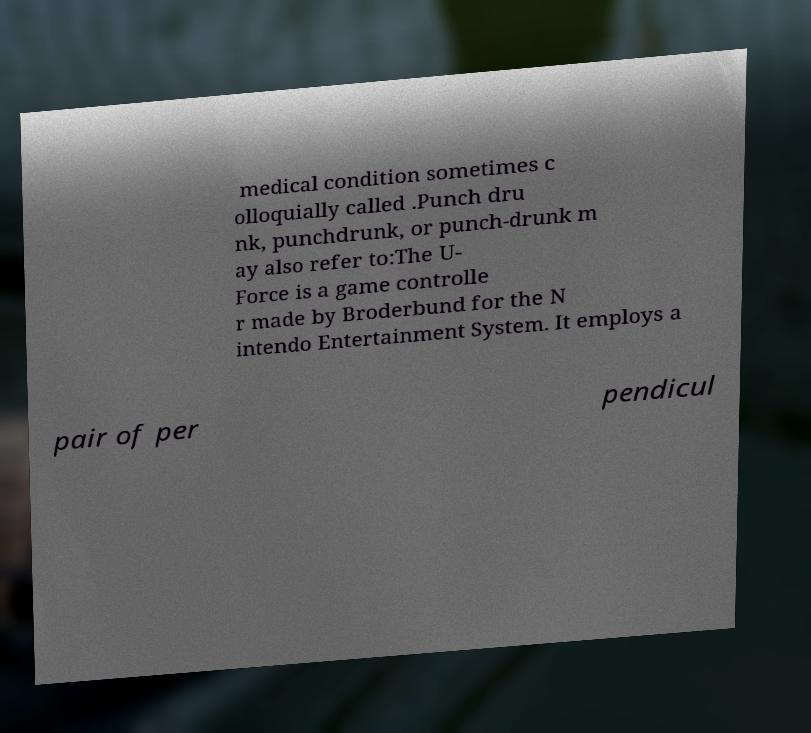There's text embedded in this image that I need extracted. Can you transcribe it verbatim? medical condition sometimes c olloquially called .Punch dru nk, punchdrunk, or punch-drunk m ay also refer to:The U- Force is a game controlle r made by Broderbund for the N intendo Entertainment System. It employs a pair of per pendicul 